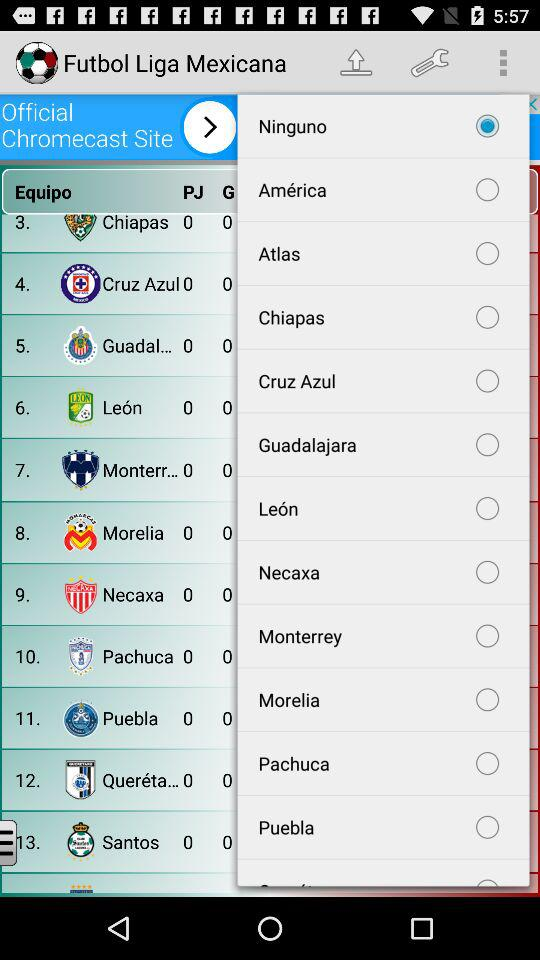Is "América" selected or not? "América" is not selected. 